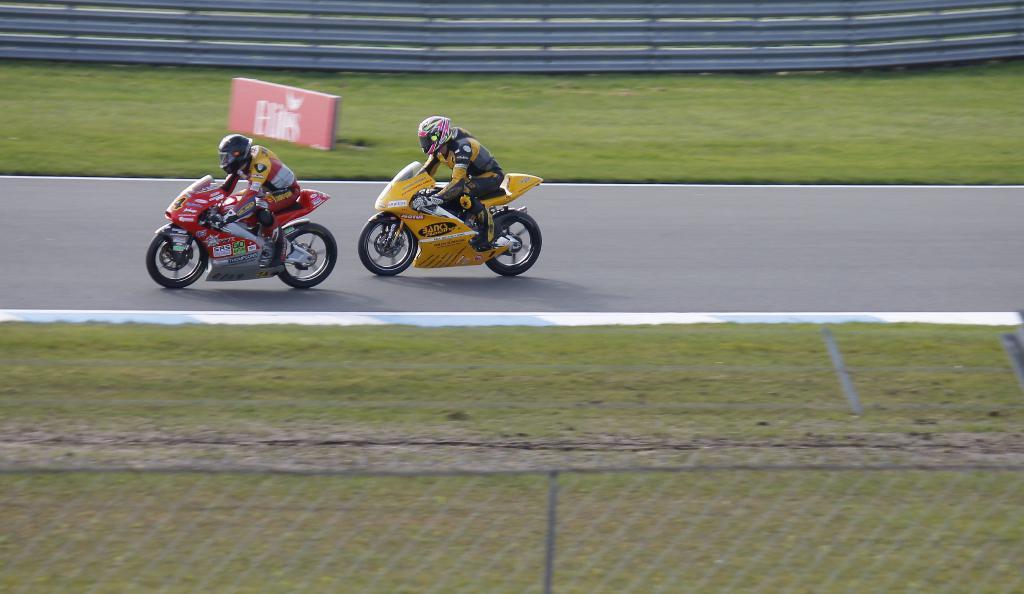Please provide a concise description of this image. In the picture we can see a racing, road on it, we can see two bikers are in sports wear and helmets and riding bikes and besides the road we can see a grass surface and in the background we can see a railing. 